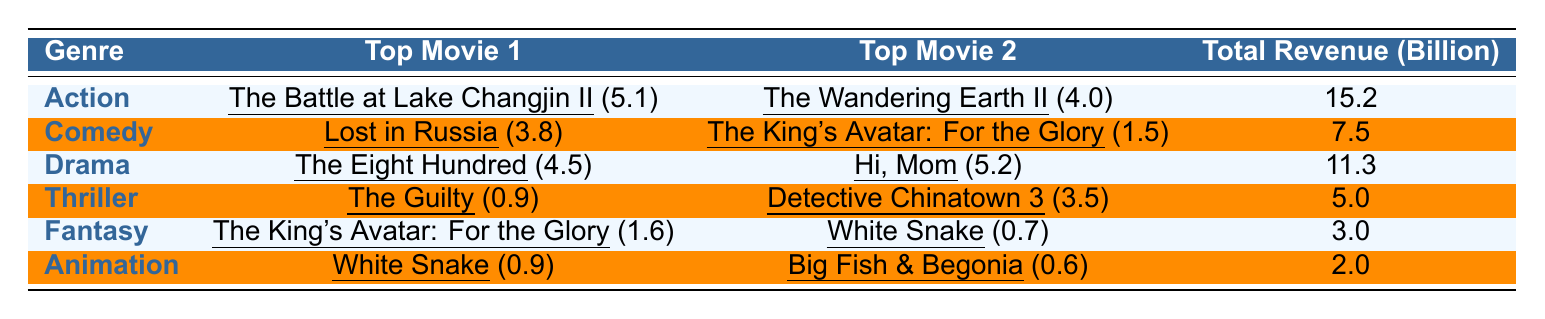What genre had the highest total revenue in 2022? The table shows that the Action genre had the highest total revenue of 15.2 billion.
Answer: Action Which two movies contributed the most revenue in the Comedy genre? The top two movies in the Comedy genre are Lost in Russia (3.8 billion) and The King's Avatar: For the Glory (1.5 billion).
Answer: Lost in Russia and The King's Avatar: For the Glory What is the total revenue of the Animation genre? According to the table, the total revenue of the Animation genre is 2.0 billion.
Answer: 2.0 billion Which genre has a total revenue less than 5 billion? The Thriller and Animation genres both have total revenues of 5.0 billion and 2.0 billion, respectively, which is less than 5 billion.
Answer: Thriller and Animation What is the average revenue of the top movies in the Drama genre? The top two movies in the Drama genre are The Eight Hundred (4.5 billion) and Hi, Mom (5.2 billion). The average is (4.5 + 5.2)/2 = 4.85 billion.
Answer: 4.85 billion Did any genre have a total revenue above 10 billion? Yes, the Action and Drama genres had total revenues of 15.2 billion and 11.3 billion, respectively, which are above 10 billion.
Answer: Yes If we combine the total revenue from Fantasy and Animation genres, what is the sum? The total revenue from the Fantasy genre is 3.0 billion and from the Animation genre is 2.0 billion. Together, they add up to 3.0 + 2.0 = 5.0 billion.
Answer: 5.0 billion Which movie has the lowest individual revenue in the table? The movie with the lowest individual revenue is White Snake, which earned 0.7 billion in the Fantasy genre.
Answer: White Snake What percentage of the total box office revenue does the Action genre represent? The total revenue across all genres is 15.2 + 7.5 + 11.3 + 5.0 + 3.0 + 2.0 = 44.0 billion. The Action genre's revenue is 15.2 billion. Thus, the percentage is (15.2/44.0) * 100 = approximately 34.55%.
Answer: 34.55% How many genres have a total revenue of 5 billion or more? The genres with total revenues of 5 billion or more are Action (15.2 billion), Drama (11.3 billion), and Comedy (7.5 billion). This sums up to three genres.
Answer: 3 genres 